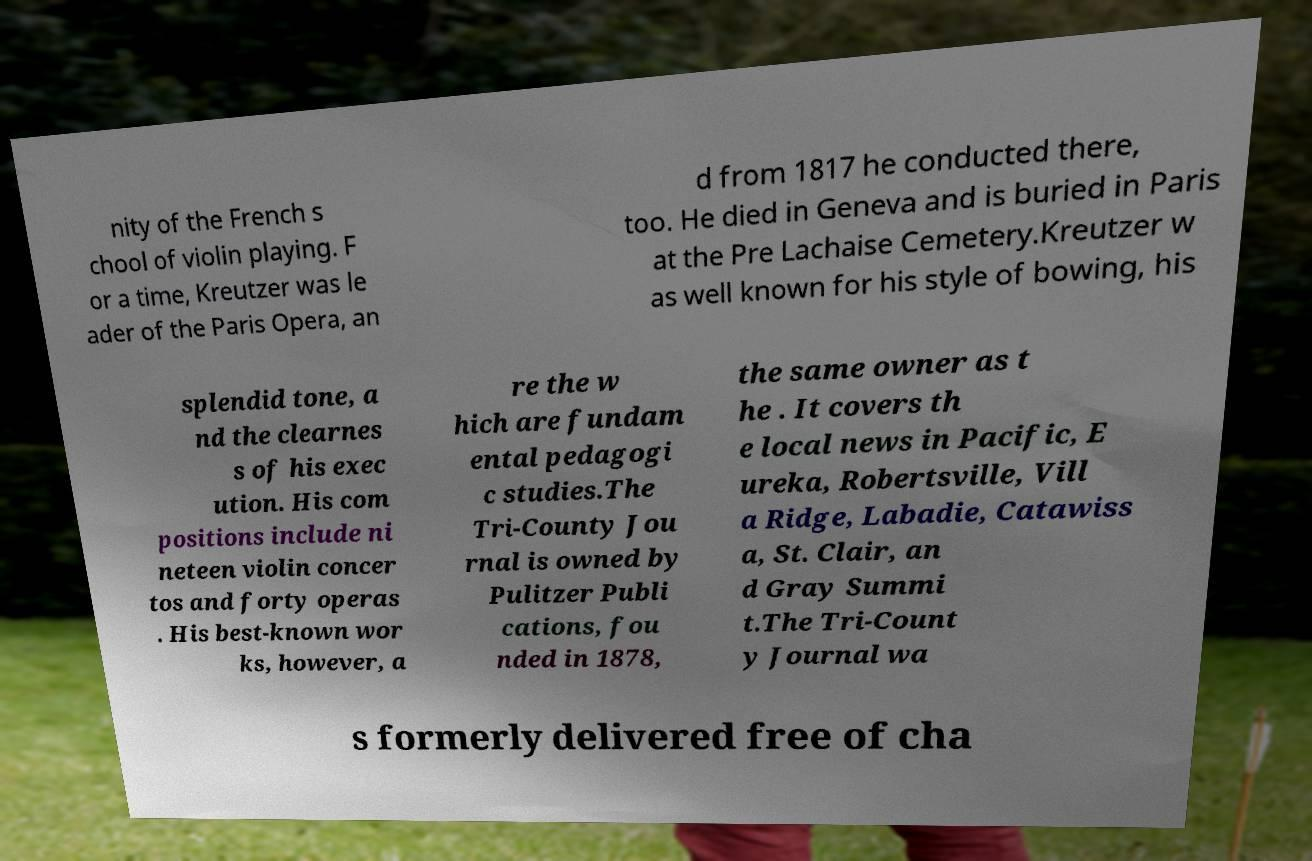Please read and relay the text visible in this image. What does it say? nity of the French s chool of violin playing. F or a time, Kreutzer was le ader of the Paris Opera, an d from 1817 he conducted there, too. He died in Geneva and is buried in Paris at the Pre Lachaise Cemetery.Kreutzer w as well known for his style of bowing, his splendid tone, a nd the clearnes s of his exec ution. His com positions include ni neteen violin concer tos and forty operas . His best-known wor ks, however, a re the w hich are fundam ental pedagogi c studies.The Tri-County Jou rnal is owned by Pulitzer Publi cations, fou nded in 1878, the same owner as t he . It covers th e local news in Pacific, E ureka, Robertsville, Vill a Ridge, Labadie, Catawiss a, St. Clair, an d Gray Summi t.The Tri-Count y Journal wa s formerly delivered free of cha 